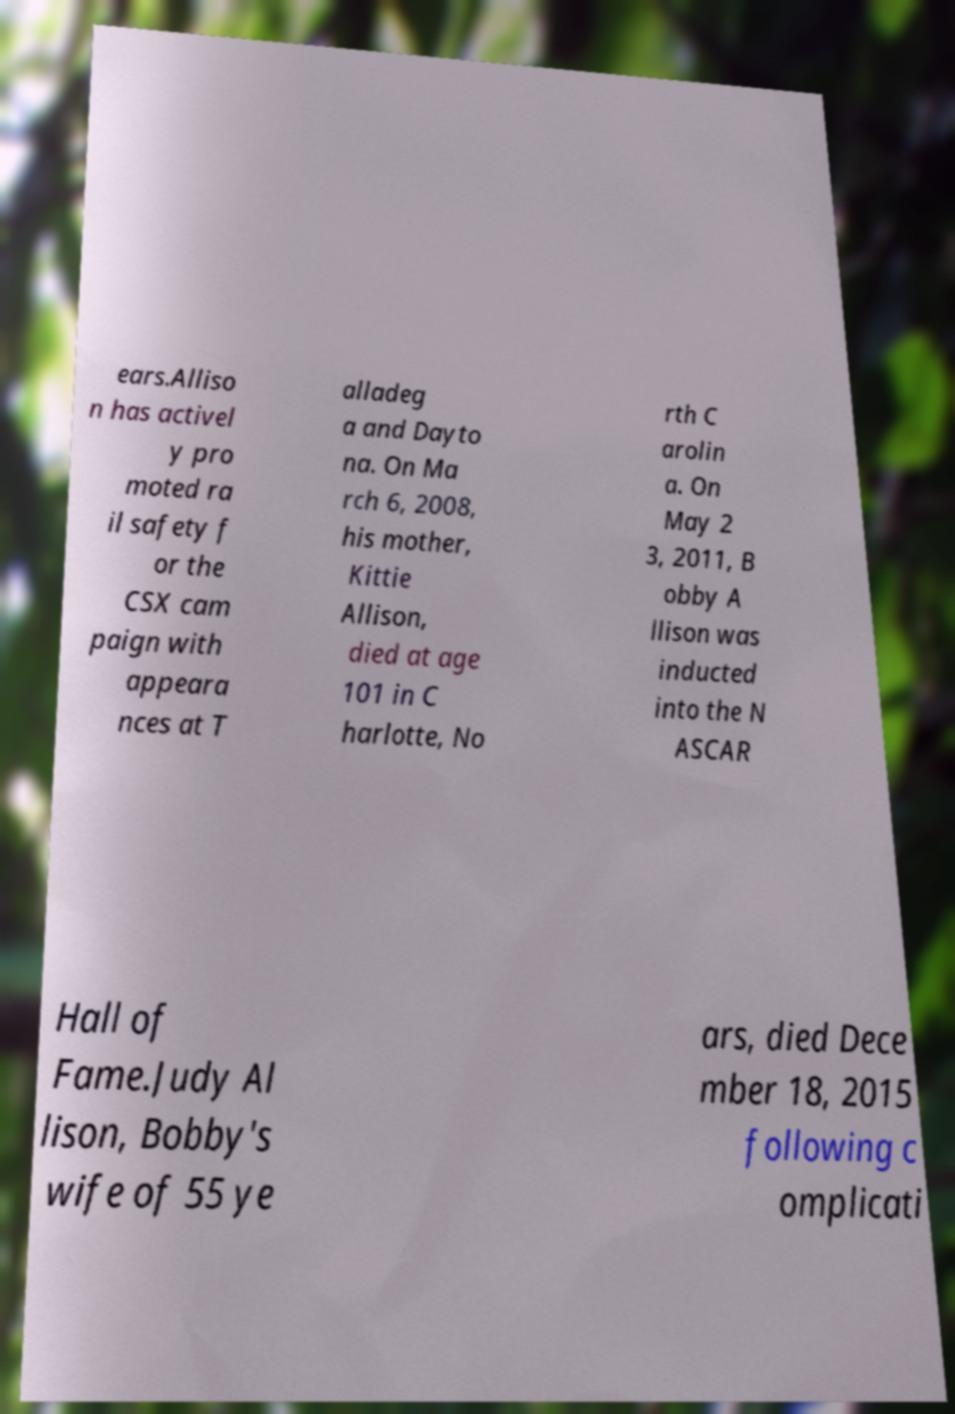Can you read and provide the text displayed in the image?This photo seems to have some interesting text. Can you extract and type it out for me? ears.Alliso n has activel y pro moted ra il safety f or the CSX cam paign with appeara nces at T alladeg a and Dayto na. On Ma rch 6, 2008, his mother, Kittie Allison, died at age 101 in C harlotte, No rth C arolin a. On May 2 3, 2011, B obby A llison was inducted into the N ASCAR Hall of Fame.Judy Al lison, Bobby's wife of 55 ye ars, died Dece mber 18, 2015 following c omplicati 